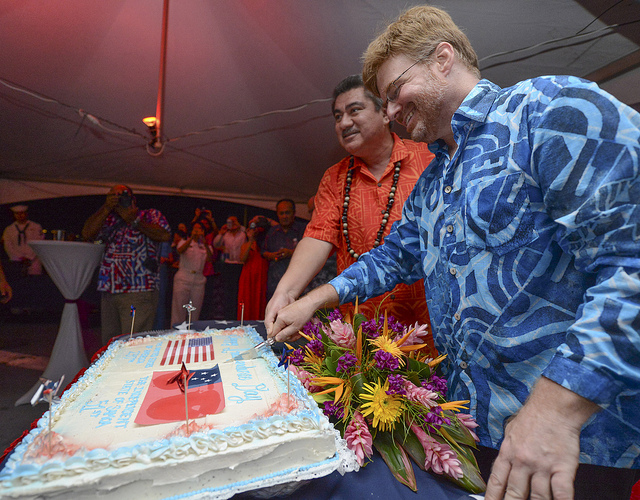Read and extract the text from this image. Day 